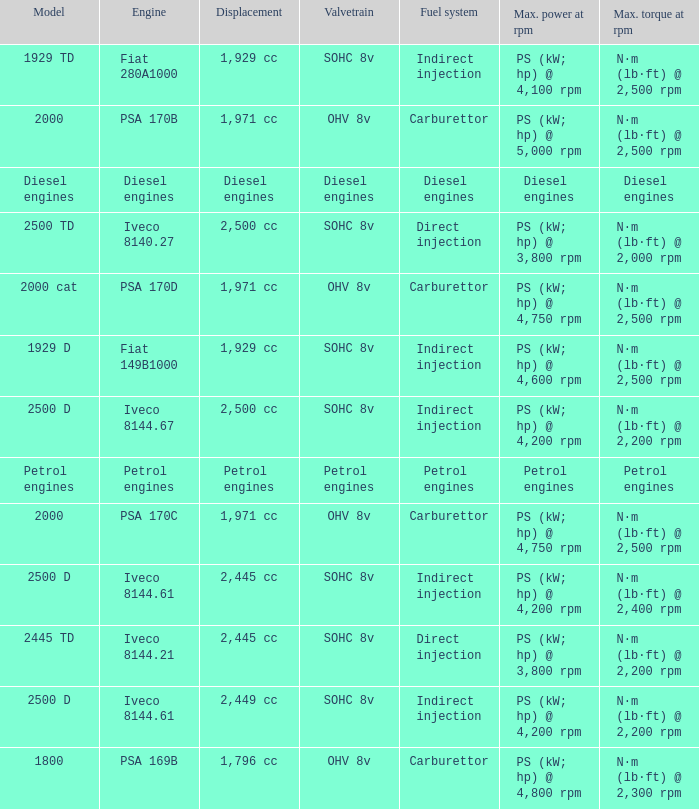What Valvetrain has a fuel system made up of petrol engines? Petrol engines. 